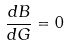Convert formula to latex. <formula><loc_0><loc_0><loc_500><loc_500>\frac { d B } { d G } = 0</formula> 